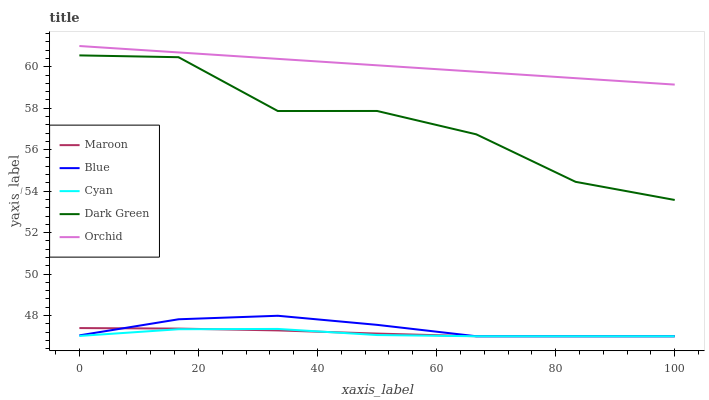Does Cyan have the minimum area under the curve?
Answer yes or no. Yes. Does Orchid have the maximum area under the curve?
Answer yes or no. Yes. Does Orchid have the minimum area under the curve?
Answer yes or no. No. Does Cyan have the maximum area under the curve?
Answer yes or no. No. Is Orchid the smoothest?
Answer yes or no. Yes. Is Dark Green the roughest?
Answer yes or no. Yes. Is Cyan the smoothest?
Answer yes or no. No. Is Cyan the roughest?
Answer yes or no. No. Does Blue have the lowest value?
Answer yes or no. Yes. Does Orchid have the lowest value?
Answer yes or no. No. Does Orchid have the highest value?
Answer yes or no. Yes. Does Cyan have the highest value?
Answer yes or no. No. Is Maroon less than Dark Green?
Answer yes or no. Yes. Is Orchid greater than Blue?
Answer yes or no. Yes. Does Blue intersect Cyan?
Answer yes or no. Yes. Is Blue less than Cyan?
Answer yes or no. No. Is Blue greater than Cyan?
Answer yes or no. No. Does Maroon intersect Dark Green?
Answer yes or no. No. 